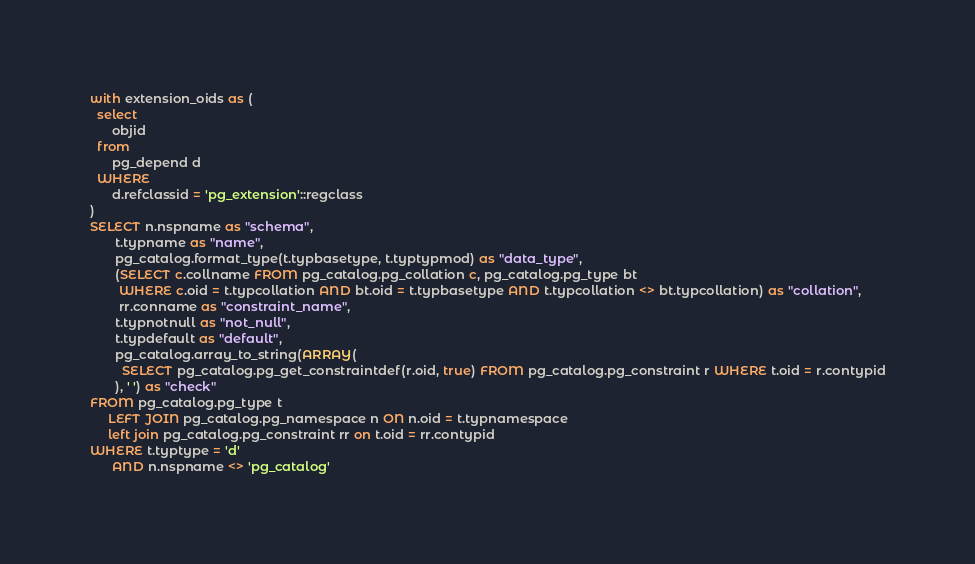<code> <loc_0><loc_0><loc_500><loc_500><_SQL_>with extension_oids as (
  select
      objid
  from
      pg_depend d
  WHERE
      d.refclassid = 'pg_extension'::regclass
)
SELECT n.nspname as "schema",
       t.typname as "name",
       pg_catalog.format_type(t.typbasetype, t.typtypmod) as "data_type",
       (SELECT c.collname FROM pg_catalog.pg_collation c, pg_catalog.pg_type bt
        WHERE c.oid = t.typcollation AND bt.oid = t.typbasetype AND t.typcollation <> bt.typcollation) as "collation",
        rr.conname as "constraint_name",
       t.typnotnull as "not_null",
       t.typdefault as "default",
       pg_catalog.array_to_string(ARRAY(
         SELECT pg_catalog.pg_get_constraintdef(r.oid, true) FROM pg_catalog.pg_constraint r WHERE t.oid = r.contypid
       ), ' ') as "check"
FROM pg_catalog.pg_type t
     LEFT JOIN pg_catalog.pg_namespace n ON n.oid = t.typnamespace
     left join pg_catalog.pg_constraint rr on t.oid = rr.contypid
WHERE t.typtype = 'd'
      AND n.nspname <> 'pg_catalog'</code> 